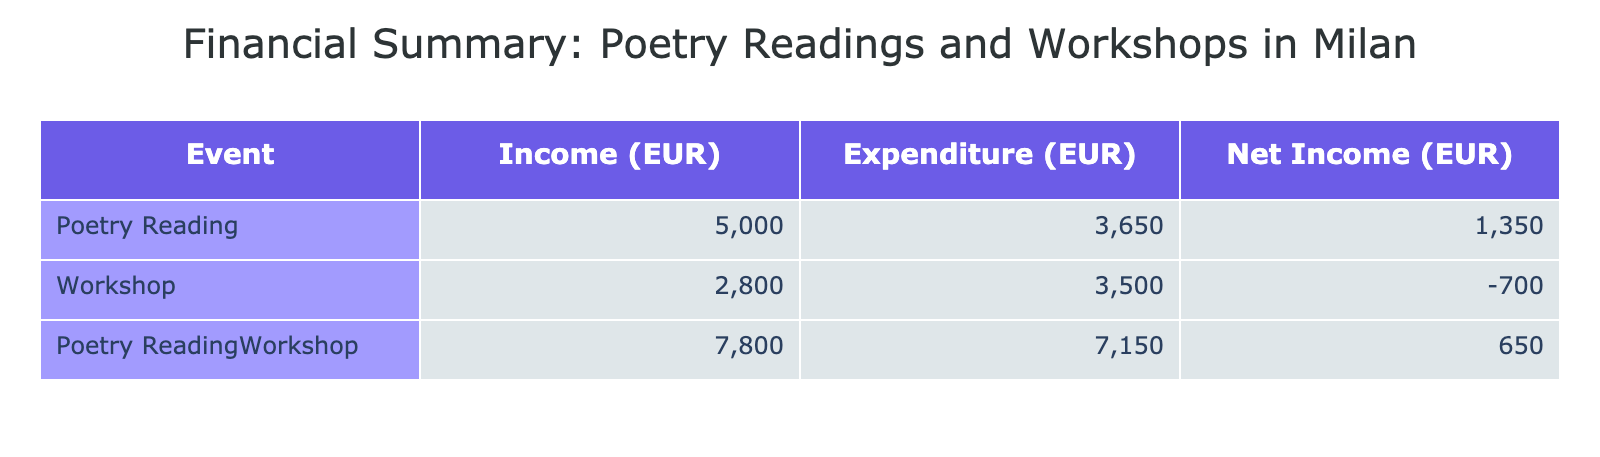What was the total income from all poetry readings? The total income from poetry readings can be calculated by summing the income values from the "Revenue" category for all poetry readings. That includes 2000 + 1500 + 300 + 1200 = 4000 EUR.
Answer: 4000 EUR What is the total expenditure on workshops? The total expenditure on workshops can be found by summing the expenditure values from the "Expenditure" category for all workshops. That includes 700 + 300 + 1200 + 900 + 400 = 3500 EUR.
Answer: 3500 EUR Which event generated the highest net income? First, we need to calculate the net income for each event by subtracting total expenditure from total income. The poetry reading net income is 4000 - (800 + 600 + 400 + 1000 + 850) = 1350 EUR, while the workshop net income is 1800 + 1000 - (700 + 300 + 1200 + 900 + 400) = -500 EUR. Therefore, the poetry readings generated the highest net income of 1350 EUR.
Answer: Poetry Reading Was the expenditure on instructor fees for workshops more than for venue rentals? To answer this, we can check the values for instructor fees and venue rentals in expenditures. The total instructor fees are 1200 + 900 = 2100 EUR, and the venue rental total is 700 EUR. Since 2100 is greater than 700, the statement is true.
Answer: Yes What is the average income per poetry reading event? First, we identify the number of poetry reading events, which is 4. Then, we sum the incomes from these events: 2000 + 1500 + 300 + 1200 = 4000 EUR. Finally, we find the average by dividing the total income by the number of events: 4000 / 4 = 1000 EUR.
Answer: 1000 EUR How much more did the poetry readings earn compared to the workshops? We first need the total income for each: poetry readings earned 4000 EUR and workshops earned 2800 EUR (1800 + 1000). Subtracting the total workshop income from the poetry readings gives 4000 - 2800 = 1200 EUR more from poetry readings.
Answer: 1200 EUR Is the total income from individual donations higher than that from ticket sales at La Scala Opera House? The total income from individual donations was 300 EUR, while ticket sales at La Scala Opera House generated 2000 EUR. Since 2000 is higher than 300, the answer is no.
Answer: No What is the net income for both the poetry reading and the workshop combined? To find the total net income, we first calculate net income for each: poetry reading net income is 1350 EUR and workshop net income is -500 EUR. Adding these gives us 1350 - 500 = 850 EUR.
Answer: 850 EUR 